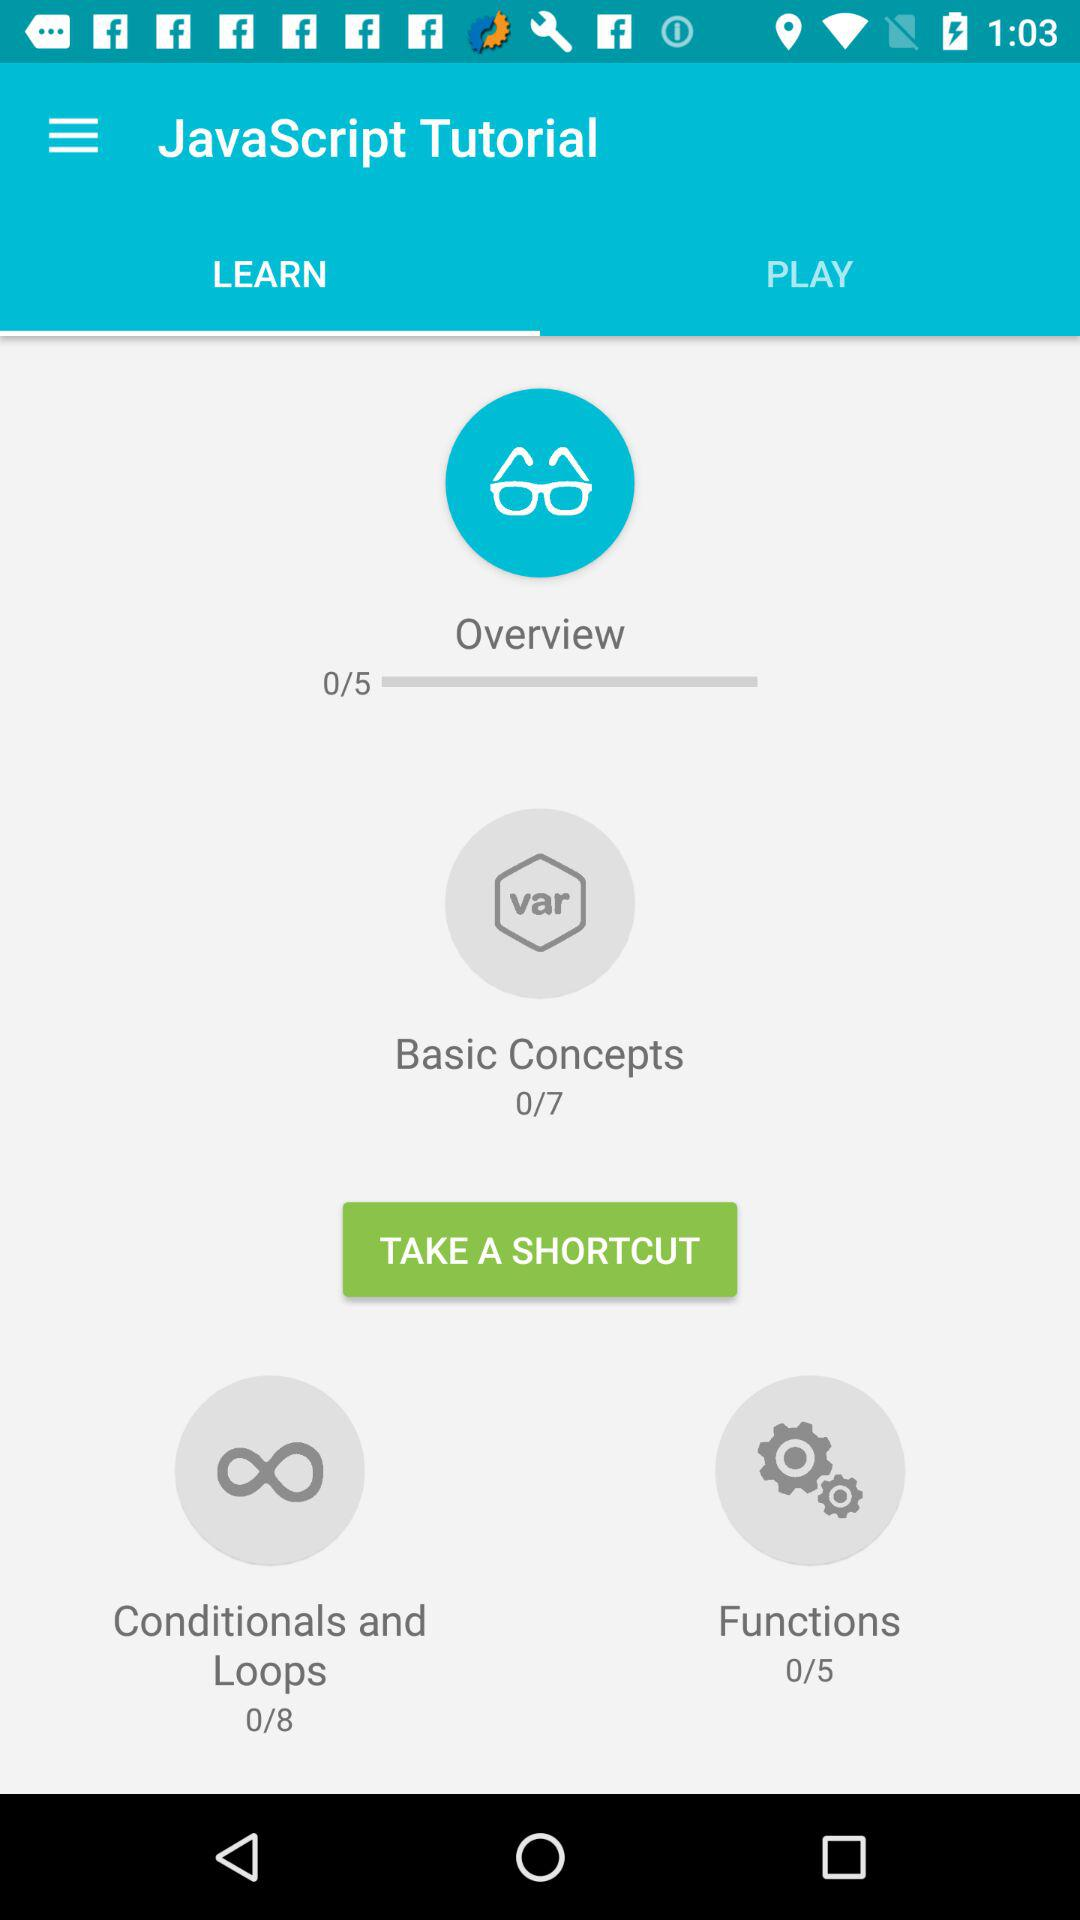How many more lessons are there in Conditionals and Loops than in Functions?
Answer the question using a single word or phrase. 3 